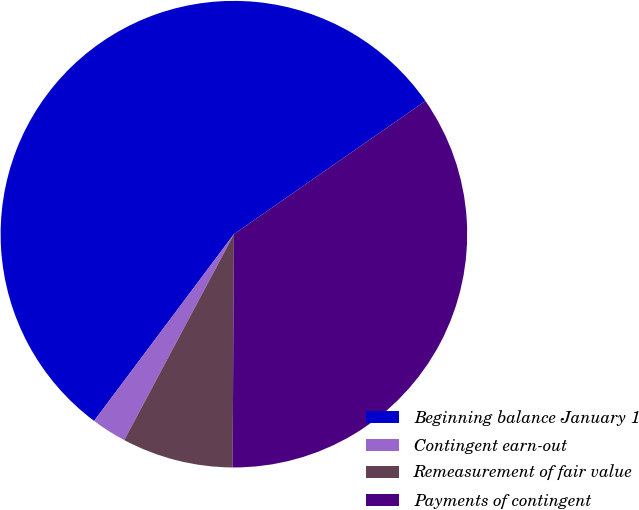<chart> <loc_0><loc_0><loc_500><loc_500><pie_chart><fcel>Beginning balance January 1<fcel>Contingent earn-out<fcel>Remeasurement of fair value<fcel>Payments of contingent<nl><fcel>55.1%<fcel>2.44%<fcel>7.7%<fcel>34.76%<nl></chart> 